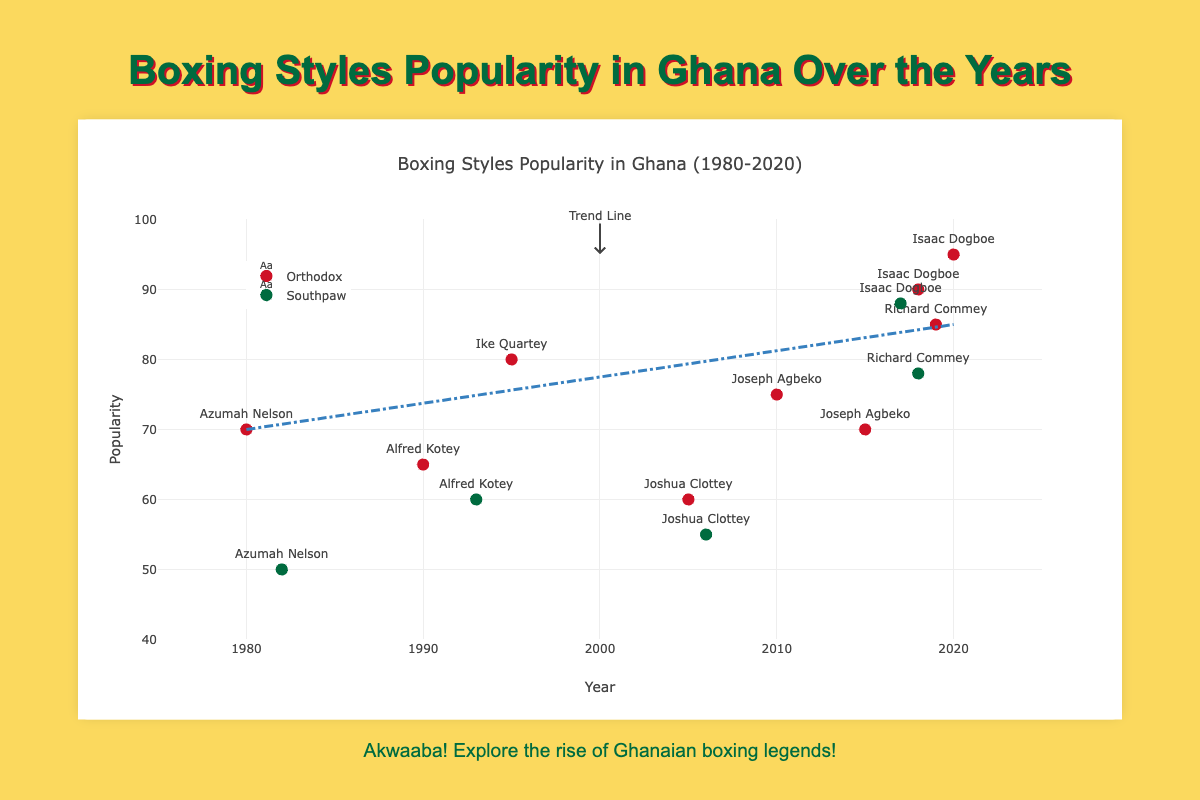What is the title of the plot? The title of the plot is displayed at the top center and it reads "Boxing Styles Popularity in Ghana Over the Years".
Answer: Boxing Styles Popularity in Ghana Over the Years What are the two styles of boxing represented in the plot? By looking at the legend to the right of the plot, we can see that there are two styles: "Orthodox" and "Southpaw".
Answer: Orthodox and Southpaw Which year shows the highest popularity value for the "Orthodox" style? By looking at the data points and their popularity values, the highest popularity for "Orthodox" is seen in the year 2020 with a value of 95.
Answer: 2020 Who is the boxer with the highest popularity in the "Southpaw" style? Observing the data points, Isaac Dogboe in the year 2017 has the highest popularity of 88 for the "Southpaw" style.
Answer: Isaac Dogboe What is the average popularity for all "Southpaw" boxers? We calculate the average popularity for "Southpaw" boxers by summing their popularity (50 + 55 + 78 + 60 + 88) and dividing by 5 (number of data points). So, (50 + 55 + 78 + 60 + 88) / 5 = 66.2.
Answer: 66.2 Compare the popularity of Azumah Nelson in 1982 when he used "Southpaw" to his popularity in 1980 when he used "Orthodox". Which style was more popular for him? Azumah Nelson's popularity was 50 in 1982 (Southpaw) and 70 in 1980 (Orthodox). The "Orthodox" style was more popular for him.
Answer: Orthodox What is the slope of the trend line shown in the plot? The trend line runs from a popularity of 70 in 1980 to a popularity of 85 in 2020. The slope (m) can be calculated as (85 - 70) / (2020 - 1980) = 0.375.
Answer: 0.375 Which boxer has data points for both "Orthodox" and "Southpaw" styles? By observing the boxing styles and names repeated in the plot, Azumah Nelson and Joshua Clottey have data points in both "Orthodox" and "Southpaw" styles.
Answer: Azumah Nelson and Joshua Clottey What is the overall trend of popularity for "Orthodox" style from 1980 to 2020? The trend line shows an increasing pattern from 70 in 1980 to 85 in 2020, indicating that the popularity for the "Orthodox" style generally increased over the years.
Answer: Increasing 